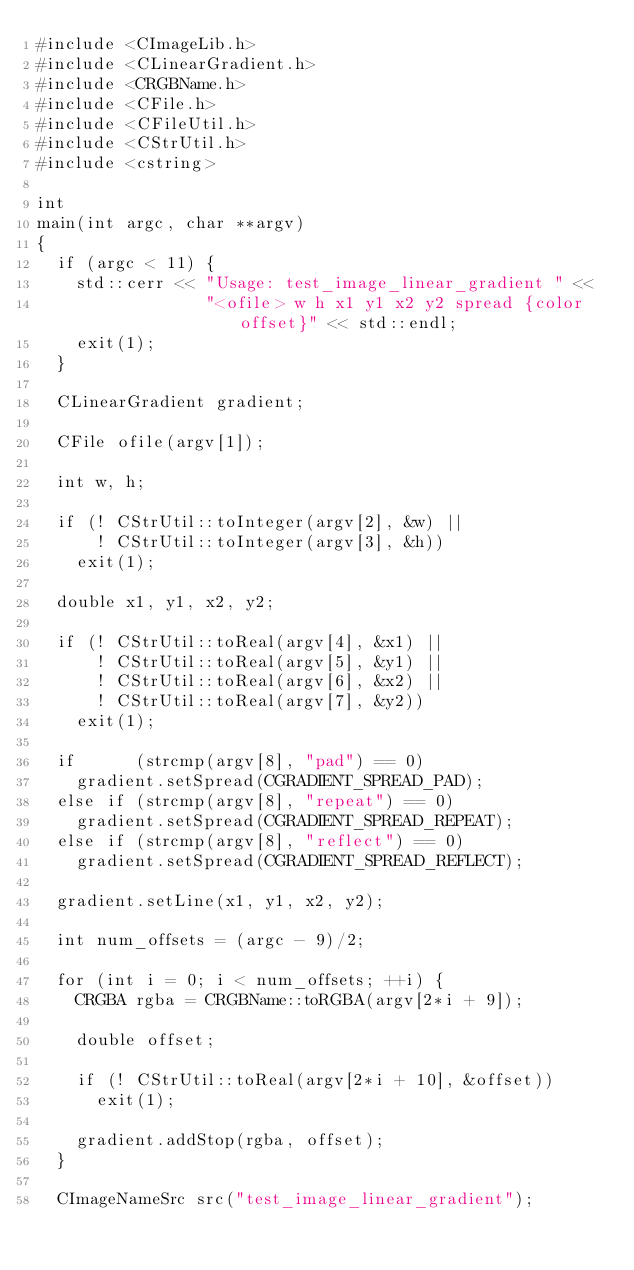Convert code to text. <code><loc_0><loc_0><loc_500><loc_500><_C++_>#include <CImageLib.h>
#include <CLinearGradient.h>
#include <CRGBName.h>
#include <CFile.h>
#include <CFileUtil.h>
#include <CStrUtil.h>
#include <cstring>

int
main(int argc, char **argv)
{
  if (argc < 11) {
    std::cerr << "Usage: test_image_linear_gradient " <<
                 "<ofile> w h x1 y1 x2 y2 spread {color offset}" << std::endl;
    exit(1);
  }

  CLinearGradient gradient;

  CFile ofile(argv[1]);

  int w, h;

  if (! CStrUtil::toInteger(argv[2], &w) ||
      ! CStrUtil::toInteger(argv[3], &h))
    exit(1);

  double x1, y1, x2, y2;

  if (! CStrUtil::toReal(argv[4], &x1) ||
      ! CStrUtil::toReal(argv[5], &y1) ||
      ! CStrUtil::toReal(argv[6], &x2) ||
      ! CStrUtil::toReal(argv[7], &y2))
    exit(1);

  if      (strcmp(argv[8], "pad") == 0)
    gradient.setSpread(CGRADIENT_SPREAD_PAD);
  else if (strcmp(argv[8], "repeat") == 0)
    gradient.setSpread(CGRADIENT_SPREAD_REPEAT);
  else if (strcmp(argv[8], "reflect") == 0)
    gradient.setSpread(CGRADIENT_SPREAD_REFLECT);

  gradient.setLine(x1, y1, x2, y2);

  int num_offsets = (argc - 9)/2;

  for (int i = 0; i < num_offsets; ++i) {
    CRGBA rgba = CRGBName::toRGBA(argv[2*i + 9]);

    double offset;

    if (! CStrUtil::toReal(argv[2*i + 10], &offset))
      exit(1);

    gradient.addStop(rgba, offset);
  }

  CImageNameSrc src("test_image_linear_gradient");
</code> 